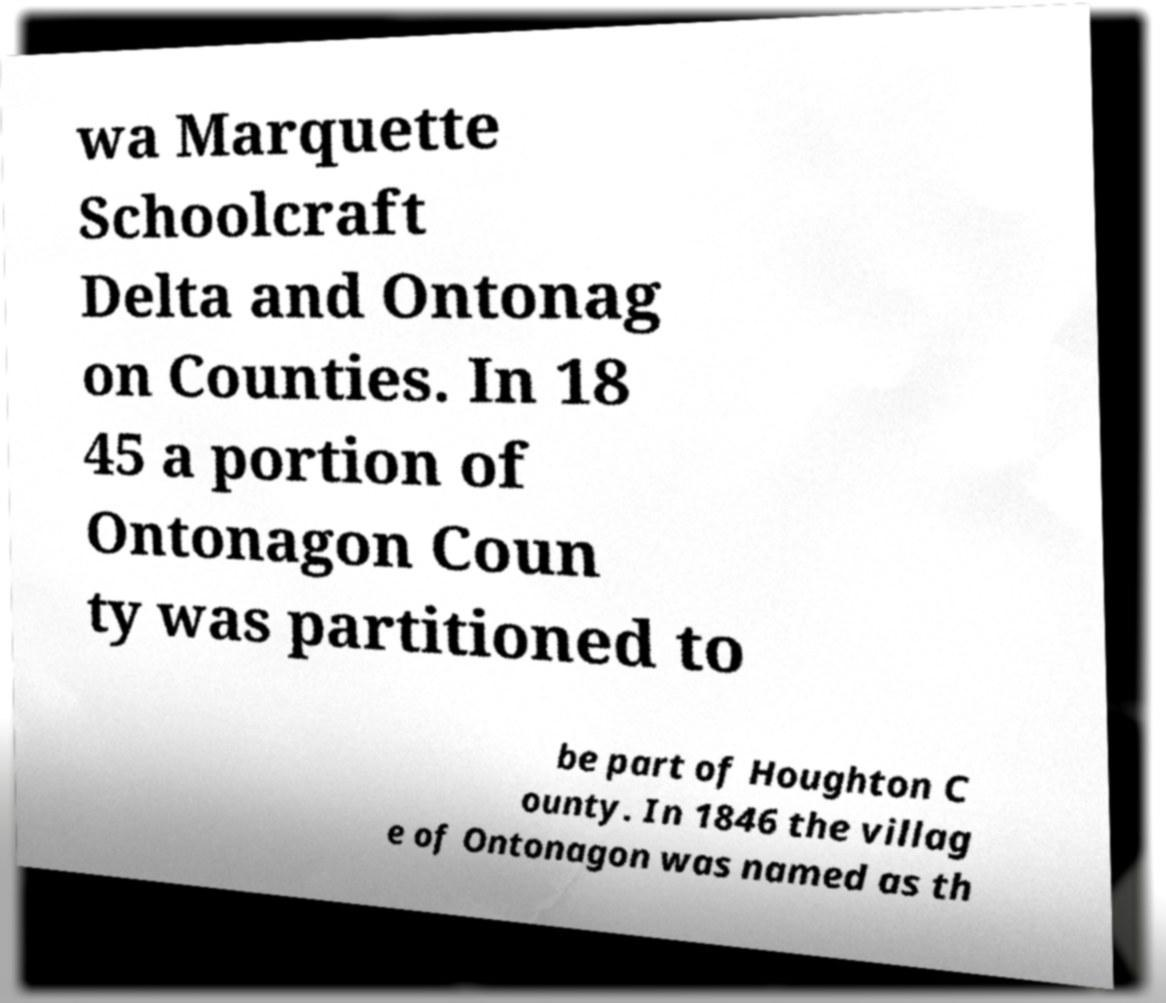Could you extract and type out the text from this image? wa Marquette Schoolcraft Delta and Ontonag on Counties. In 18 45 a portion of Ontonagon Coun ty was partitioned to be part of Houghton C ounty. In 1846 the villag e of Ontonagon was named as th 